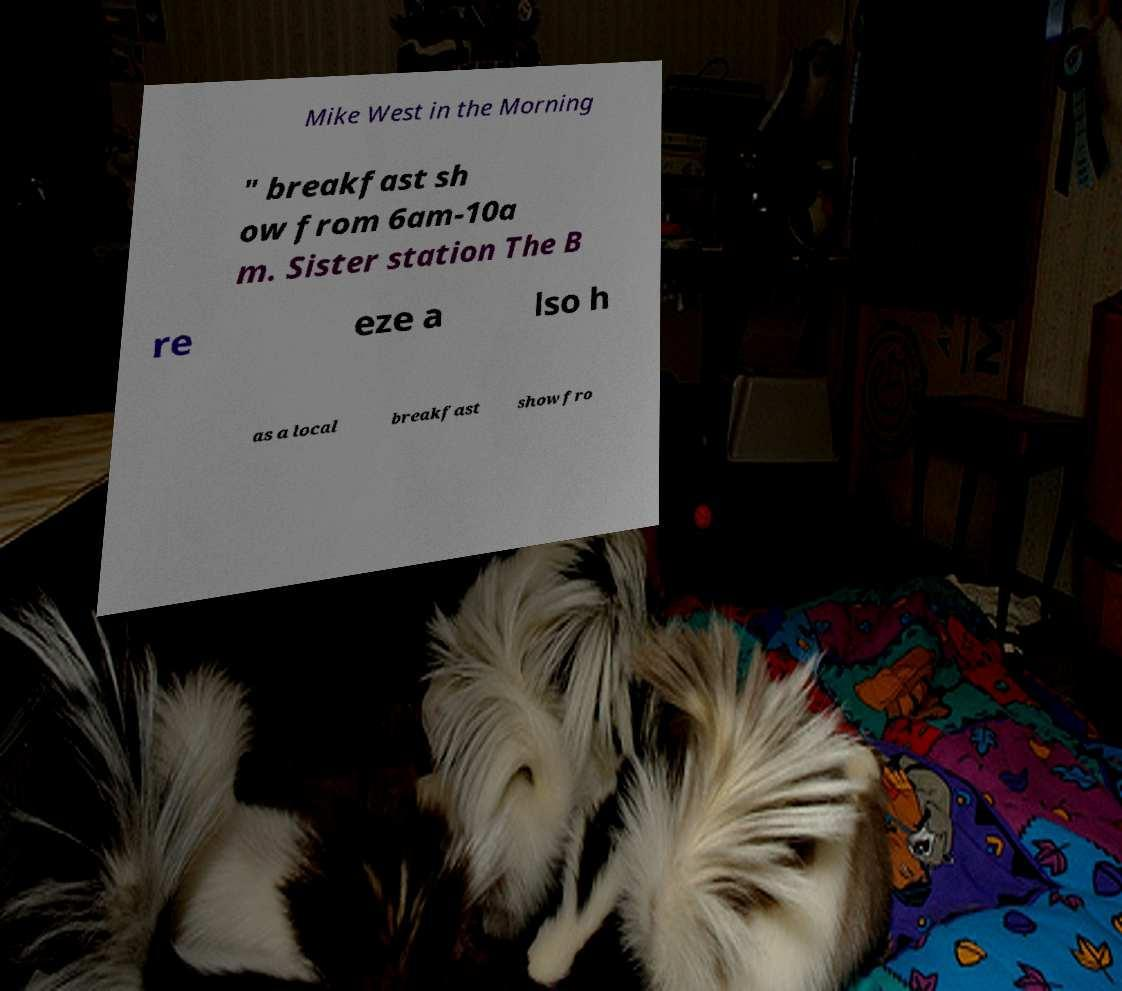Could you assist in decoding the text presented in this image and type it out clearly? Mike West in the Morning " breakfast sh ow from 6am-10a m. Sister station The B re eze a lso h as a local breakfast show fro 